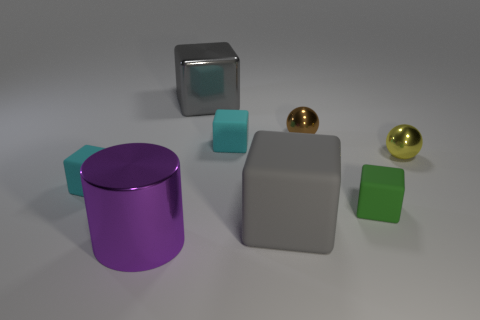What number of big objects are brown spheres or purple metal cylinders?
Keep it short and to the point. 1. Is the number of large gray rubber cubes greater than the number of tiny metal cubes?
Keep it short and to the point. Yes. What number of small cyan matte blocks are in front of the gray block to the right of the metal object that is behind the small brown object?
Give a very brief answer. 0. What shape is the big purple shiny object?
Offer a very short reply. Cylinder. What number of other things are there of the same material as the tiny brown thing
Make the answer very short. 3. Is the size of the gray metal cube the same as the purple metal object?
Make the answer very short. Yes. What shape is the gray shiny object that is on the left side of the brown metal sphere?
Keep it short and to the point. Cube. The small block that is behind the cyan thing in front of the small yellow thing is what color?
Offer a very short reply. Cyan. Is the shape of the small metal object to the left of the small yellow thing the same as the tiny metal thing right of the small brown sphere?
Keep it short and to the point. Yes. What is the shape of the green thing that is the same size as the brown thing?
Make the answer very short. Cube. 